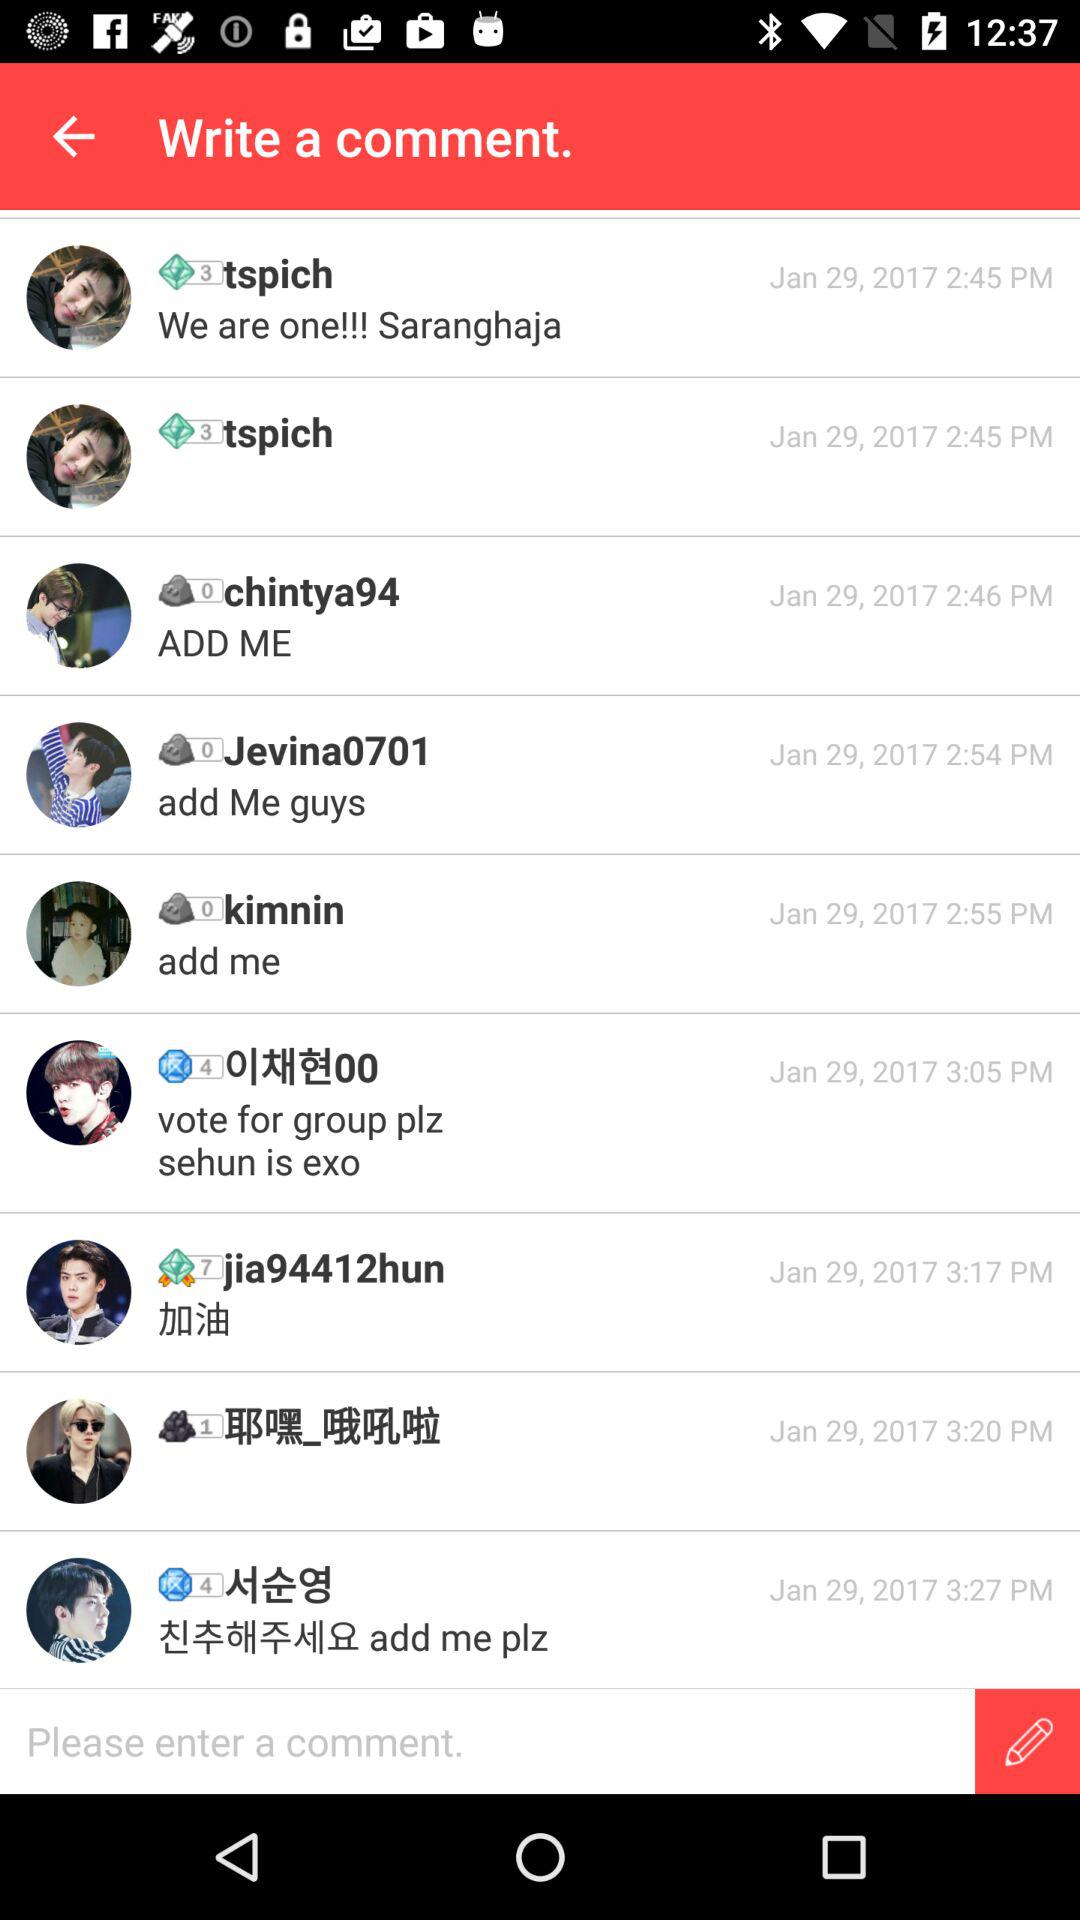What was the comment updated by Kimnin? The comment was "add me". 